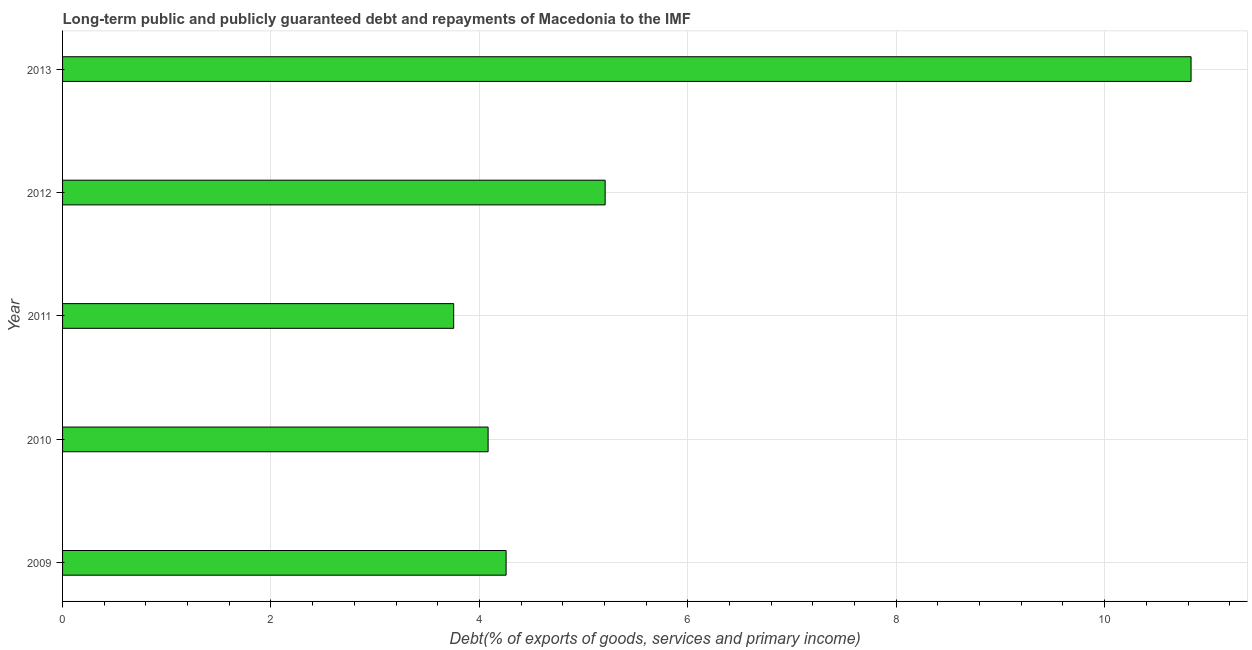Does the graph contain any zero values?
Offer a terse response. No. Does the graph contain grids?
Offer a very short reply. Yes. What is the title of the graph?
Give a very brief answer. Long-term public and publicly guaranteed debt and repayments of Macedonia to the IMF. What is the label or title of the X-axis?
Your answer should be very brief. Debt(% of exports of goods, services and primary income). What is the label or title of the Y-axis?
Give a very brief answer. Year. What is the debt service in 2009?
Your response must be concise. 4.26. Across all years, what is the maximum debt service?
Your answer should be compact. 10.83. Across all years, what is the minimum debt service?
Your response must be concise. 3.75. In which year was the debt service maximum?
Offer a very short reply. 2013. What is the sum of the debt service?
Your response must be concise. 28.13. What is the difference between the debt service in 2011 and 2013?
Keep it short and to the point. -7.08. What is the average debt service per year?
Keep it short and to the point. 5.63. What is the median debt service?
Offer a very short reply. 4.26. In how many years, is the debt service greater than 1.6 %?
Give a very brief answer. 5. What is the ratio of the debt service in 2012 to that in 2013?
Provide a short and direct response. 0.48. Is the debt service in 2011 less than that in 2012?
Your answer should be compact. Yes. What is the difference between the highest and the second highest debt service?
Give a very brief answer. 5.62. What is the difference between the highest and the lowest debt service?
Your response must be concise. 7.08. How many bars are there?
Make the answer very short. 5. Are all the bars in the graph horizontal?
Provide a succinct answer. Yes. How many years are there in the graph?
Make the answer very short. 5. What is the difference between two consecutive major ticks on the X-axis?
Make the answer very short. 2. Are the values on the major ticks of X-axis written in scientific E-notation?
Give a very brief answer. No. What is the Debt(% of exports of goods, services and primary income) of 2009?
Offer a very short reply. 4.26. What is the Debt(% of exports of goods, services and primary income) in 2010?
Keep it short and to the point. 4.08. What is the Debt(% of exports of goods, services and primary income) of 2011?
Your answer should be compact. 3.75. What is the Debt(% of exports of goods, services and primary income) of 2012?
Your answer should be very brief. 5.21. What is the Debt(% of exports of goods, services and primary income) in 2013?
Provide a succinct answer. 10.83. What is the difference between the Debt(% of exports of goods, services and primary income) in 2009 and 2010?
Give a very brief answer. 0.17. What is the difference between the Debt(% of exports of goods, services and primary income) in 2009 and 2011?
Make the answer very short. 0.5. What is the difference between the Debt(% of exports of goods, services and primary income) in 2009 and 2012?
Provide a succinct answer. -0.95. What is the difference between the Debt(% of exports of goods, services and primary income) in 2009 and 2013?
Your response must be concise. -6.57. What is the difference between the Debt(% of exports of goods, services and primary income) in 2010 and 2011?
Provide a succinct answer. 0.33. What is the difference between the Debt(% of exports of goods, services and primary income) in 2010 and 2012?
Your answer should be very brief. -1.12. What is the difference between the Debt(% of exports of goods, services and primary income) in 2010 and 2013?
Ensure brevity in your answer.  -6.75. What is the difference between the Debt(% of exports of goods, services and primary income) in 2011 and 2012?
Give a very brief answer. -1.45. What is the difference between the Debt(% of exports of goods, services and primary income) in 2011 and 2013?
Offer a very short reply. -7.08. What is the difference between the Debt(% of exports of goods, services and primary income) in 2012 and 2013?
Give a very brief answer. -5.62. What is the ratio of the Debt(% of exports of goods, services and primary income) in 2009 to that in 2010?
Provide a succinct answer. 1.04. What is the ratio of the Debt(% of exports of goods, services and primary income) in 2009 to that in 2011?
Ensure brevity in your answer.  1.13. What is the ratio of the Debt(% of exports of goods, services and primary income) in 2009 to that in 2012?
Your answer should be compact. 0.82. What is the ratio of the Debt(% of exports of goods, services and primary income) in 2009 to that in 2013?
Provide a succinct answer. 0.39. What is the ratio of the Debt(% of exports of goods, services and primary income) in 2010 to that in 2011?
Give a very brief answer. 1.09. What is the ratio of the Debt(% of exports of goods, services and primary income) in 2010 to that in 2012?
Make the answer very short. 0.78. What is the ratio of the Debt(% of exports of goods, services and primary income) in 2010 to that in 2013?
Make the answer very short. 0.38. What is the ratio of the Debt(% of exports of goods, services and primary income) in 2011 to that in 2012?
Provide a succinct answer. 0.72. What is the ratio of the Debt(% of exports of goods, services and primary income) in 2011 to that in 2013?
Provide a short and direct response. 0.35. What is the ratio of the Debt(% of exports of goods, services and primary income) in 2012 to that in 2013?
Provide a succinct answer. 0.48. 